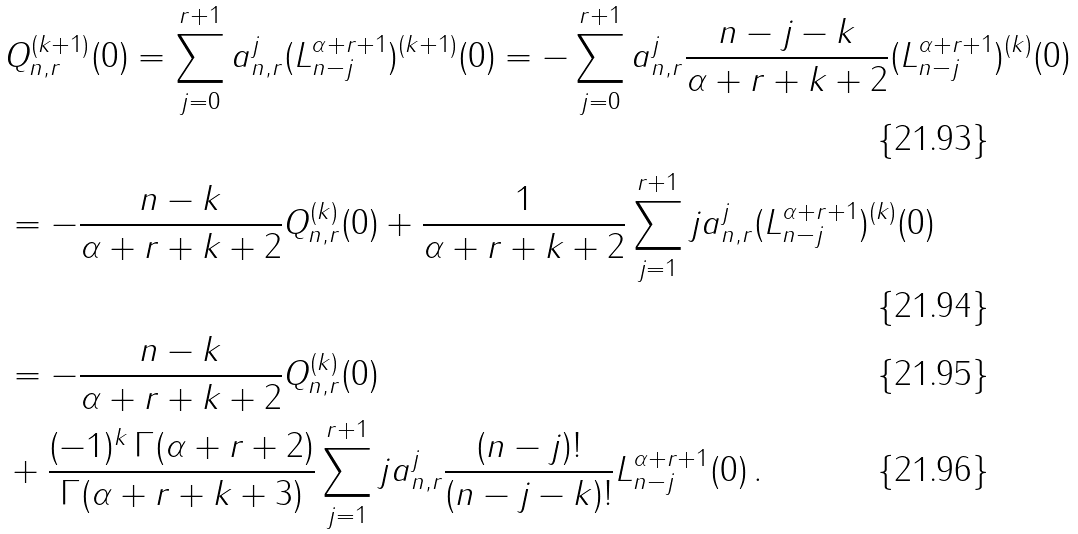Convert formula to latex. <formula><loc_0><loc_0><loc_500><loc_500>& Q _ { n , r } ^ { ( k + 1 ) } ( 0 ) = \sum _ { j = 0 } ^ { r + 1 } a _ { n , r } ^ { j } ( L _ { n - j } ^ { \alpha + r + 1 } ) ^ { ( k + 1 ) } ( 0 ) = - \sum _ { j = 0 } ^ { r + 1 } a _ { n , r } ^ { j } \frac { n - j - k } { \alpha + r + k + 2 } ( L _ { n - j } ^ { \alpha + r + 1 } ) ^ { ( k ) } ( 0 ) \\ & = - \frac { n - k } { \alpha + r + k + 2 } Q _ { n , r } ^ { ( k ) } ( 0 ) + \frac { 1 } { \alpha + r + k + 2 } \sum _ { j = 1 } ^ { r + 1 } j a _ { n , r } ^ { j } ( L _ { n - j } ^ { \alpha + r + 1 } ) ^ { ( k ) } ( 0 ) \\ & = - \frac { n - k } { \alpha + r + k + 2 } Q _ { n , r } ^ { ( k ) } ( 0 ) \\ & + \frac { ( - 1 ) ^ { k } \, \Gamma ( \alpha + r + 2 ) } { \Gamma ( \alpha + r + k + 3 ) } \sum _ { j = 1 } ^ { r + 1 } j a _ { n , r } ^ { j } \frac { ( n - j ) ! } { ( n - j - k ) ! } L _ { n - j } ^ { \alpha + r + 1 } ( 0 ) \, .</formula> 